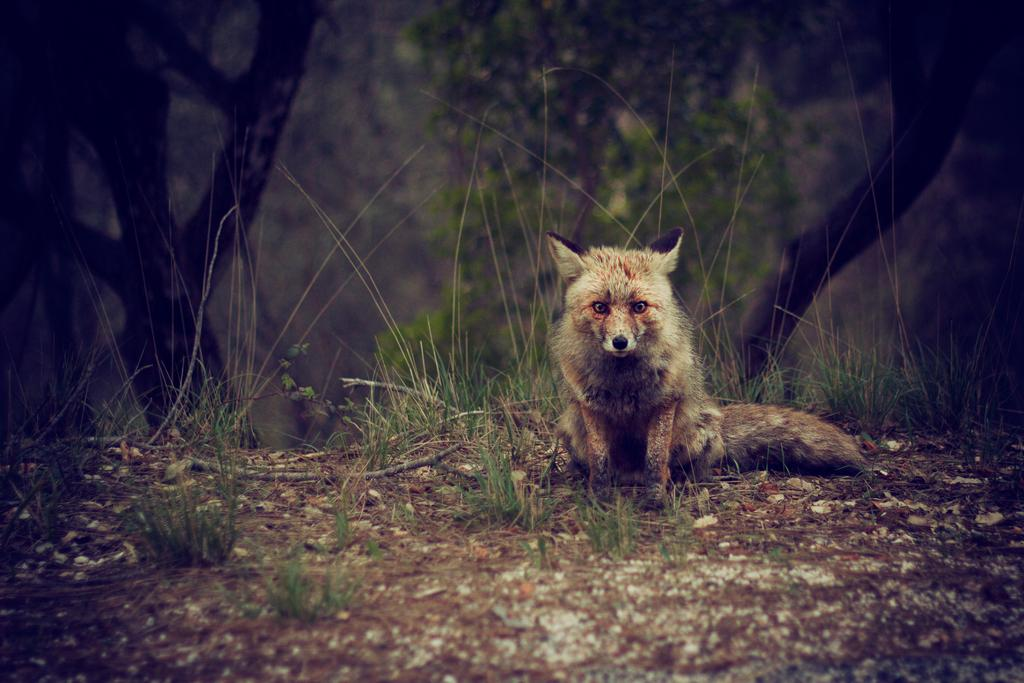What animal is in the foreground of the image? There is a fox in the foreground of the image. What is the fox's position in relation to the ground? The fox is on the ground. What type of vegetation is present in the foreground of the image? There is grass in the foreground of the image. What can be seen in the background of the image? There are trees in the background of the image. What might be the setting of the image based on the presence of trees? The image may have been taken in a forest. What time of day might the image have been taken based on the lighting? The image may have been taken during the night. Where is the faucet located in the image? There is no faucet present in the image. What type of waste is being disposed of by the giants in the image? There are no giants or waste present in the image. 